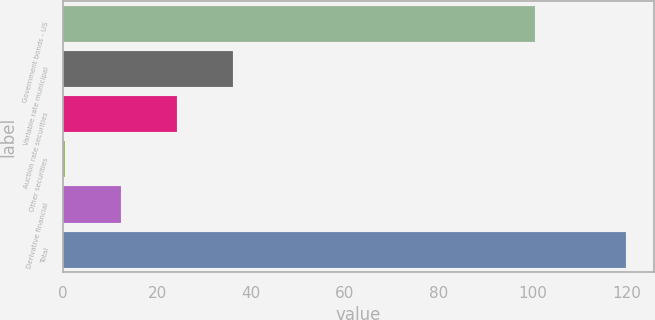Convert chart to OTSL. <chart><loc_0><loc_0><loc_500><loc_500><bar_chart><fcel>Government bonds - US<fcel>Variable rate municipal<fcel>Auction rate securities<fcel>Other securities<fcel>Derivative financial<fcel>Total<nl><fcel>100.4<fcel>36.26<fcel>24.34<fcel>0.5<fcel>12.42<fcel>119.7<nl></chart> 